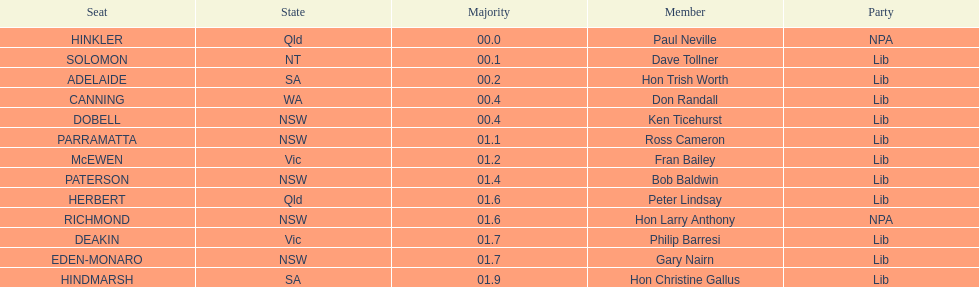What member comes next after hon trish worth? Don Randall. Give me the full table as a dictionary. {'header': ['Seat', 'State', 'Majority', 'Member', 'Party'], 'rows': [['HINKLER', 'Qld', '00.0', 'Paul Neville', 'NPA'], ['SOLOMON', 'NT', '00.1', 'Dave Tollner', 'Lib'], ['ADELAIDE', 'SA', '00.2', 'Hon Trish Worth', 'Lib'], ['CANNING', 'WA', '00.4', 'Don Randall', 'Lib'], ['DOBELL', 'NSW', '00.4', 'Ken Ticehurst', 'Lib'], ['PARRAMATTA', 'NSW', '01.1', 'Ross Cameron', 'Lib'], ['McEWEN', 'Vic', '01.2', 'Fran Bailey', 'Lib'], ['PATERSON', 'NSW', '01.4', 'Bob Baldwin', 'Lib'], ['HERBERT', 'Qld', '01.6', 'Peter Lindsay', 'Lib'], ['RICHMOND', 'NSW', '01.6', 'Hon Larry Anthony', 'NPA'], ['DEAKIN', 'Vic', '01.7', 'Philip Barresi', 'Lib'], ['EDEN-MONARO', 'NSW', '01.7', 'Gary Nairn', 'Lib'], ['HINDMARSH', 'SA', '01.9', 'Hon Christine Gallus', 'Lib']]} 